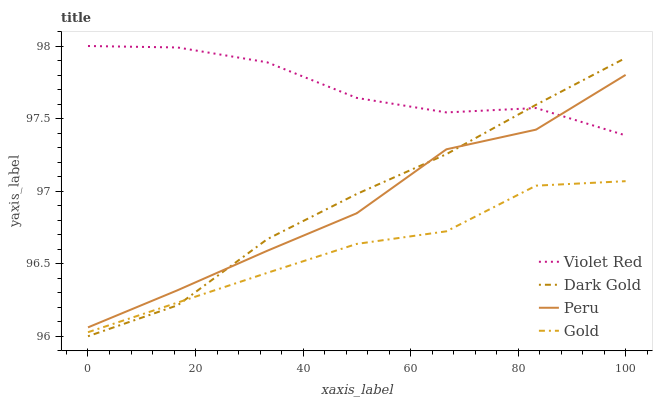Does Gold have the minimum area under the curve?
Answer yes or no. Yes. Does Violet Red have the maximum area under the curve?
Answer yes or no. Yes. Does Peru have the minimum area under the curve?
Answer yes or no. No. Does Peru have the maximum area under the curve?
Answer yes or no. No. Is Dark Gold the smoothest?
Answer yes or no. Yes. Is Peru the roughest?
Answer yes or no. Yes. Is Gold the smoothest?
Answer yes or no. No. Is Gold the roughest?
Answer yes or no. No. Does Dark Gold have the lowest value?
Answer yes or no. Yes. Does Gold have the lowest value?
Answer yes or no. No. Does Violet Red have the highest value?
Answer yes or no. Yes. Does Peru have the highest value?
Answer yes or no. No. Is Gold less than Violet Red?
Answer yes or no. Yes. Is Peru greater than Gold?
Answer yes or no. Yes. Does Violet Red intersect Dark Gold?
Answer yes or no. Yes. Is Violet Red less than Dark Gold?
Answer yes or no. No. Is Violet Red greater than Dark Gold?
Answer yes or no. No. Does Gold intersect Violet Red?
Answer yes or no. No. 